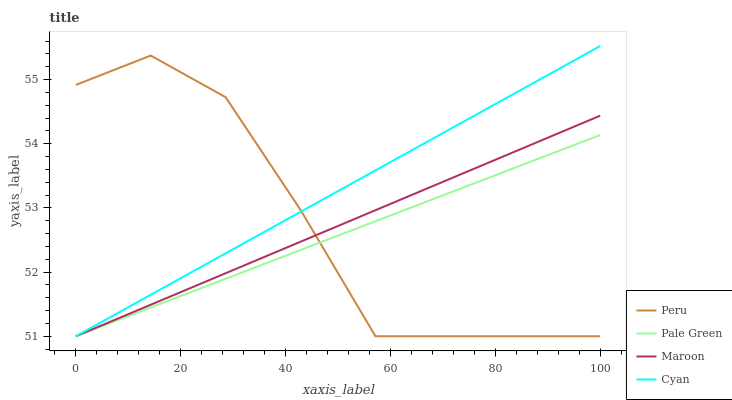Does Pale Green have the minimum area under the curve?
Answer yes or no. Yes. Does Cyan have the maximum area under the curve?
Answer yes or no. Yes. Does Maroon have the minimum area under the curve?
Answer yes or no. No. Does Maroon have the maximum area under the curve?
Answer yes or no. No. Is Pale Green the smoothest?
Answer yes or no. Yes. Is Peru the roughest?
Answer yes or no. Yes. Is Peru the smoothest?
Answer yes or no. No. Is Maroon the roughest?
Answer yes or no. No. Does Cyan have the lowest value?
Answer yes or no. Yes. Does Cyan have the highest value?
Answer yes or no. Yes. Does Maroon have the highest value?
Answer yes or no. No. Does Cyan intersect Pale Green?
Answer yes or no. Yes. Is Cyan less than Pale Green?
Answer yes or no. No. Is Cyan greater than Pale Green?
Answer yes or no. No. 